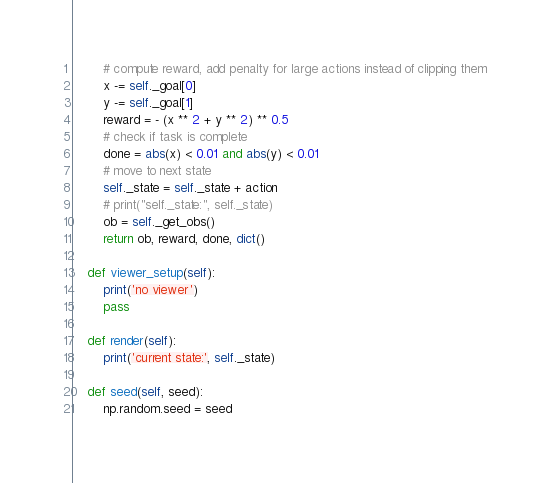<code> <loc_0><loc_0><loc_500><loc_500><_Python_>        # compute reward, add penalty for large actions instead of clipping them
        x -= self._goal[0]
        y -= self._goal[1]
        reward = - (x ** 2 + y ** 2) ** 0.5
        # check if task is complete
        done = abs(x) < 0.01 and abs(y) < 0.01
        # move to next state
        self._state = self._state + action
        # print("self._state:", self._state)
        ob = self._get_obs()
        return ob, reward, done, dict()

    def viewer_setup(self):
        print('no viewer')
        pass

    def render(self):
        print('current state:', self._state)

    def seed(self, seed):
        np.random.seed = seed
</code> 